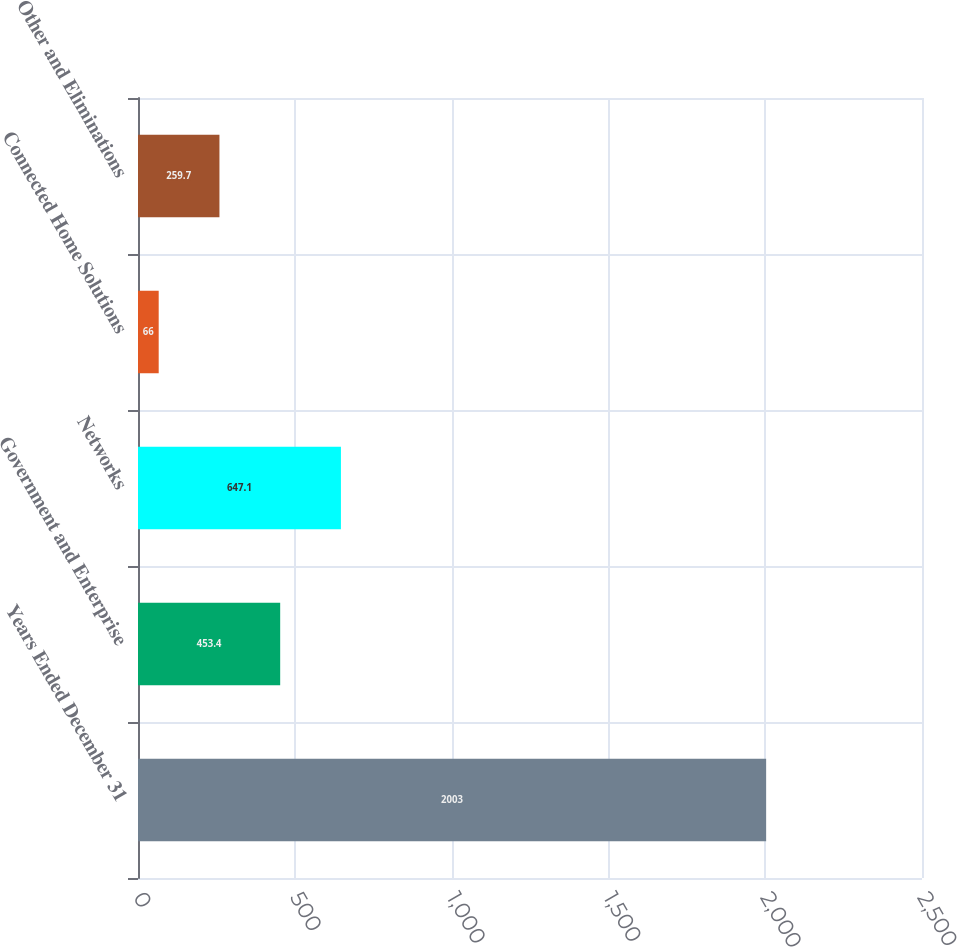<chart> <loc_0><loc_0><loc_500><loc_500><bar_chart><fcel>Years Ended December 31<fcel>Government and Enterprise<fcel>Networks<fcel>Connected Home Solutions<fcel>Other and Eliminations<nl><fcel>2003<fcel>453.4<fcel>647.1<fcel>66<fcel>259.7<nl></chart> 